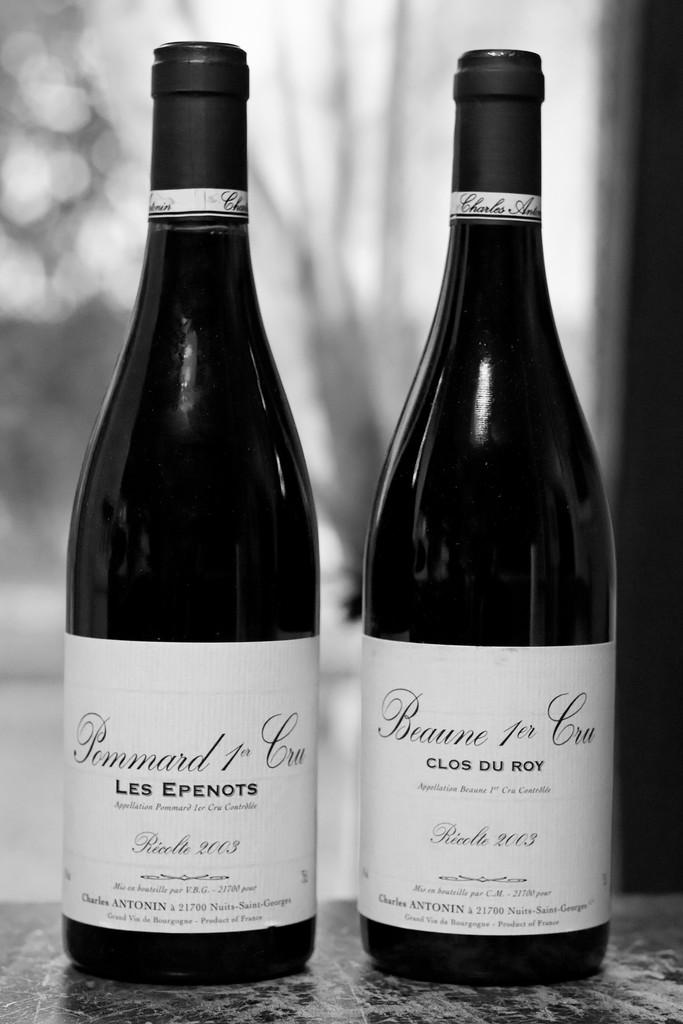What year was the clos du roy made?
Make the answer very short. 2003. What brand is the beverage?
Your answer should be very brief. Pommard 1er cru. 